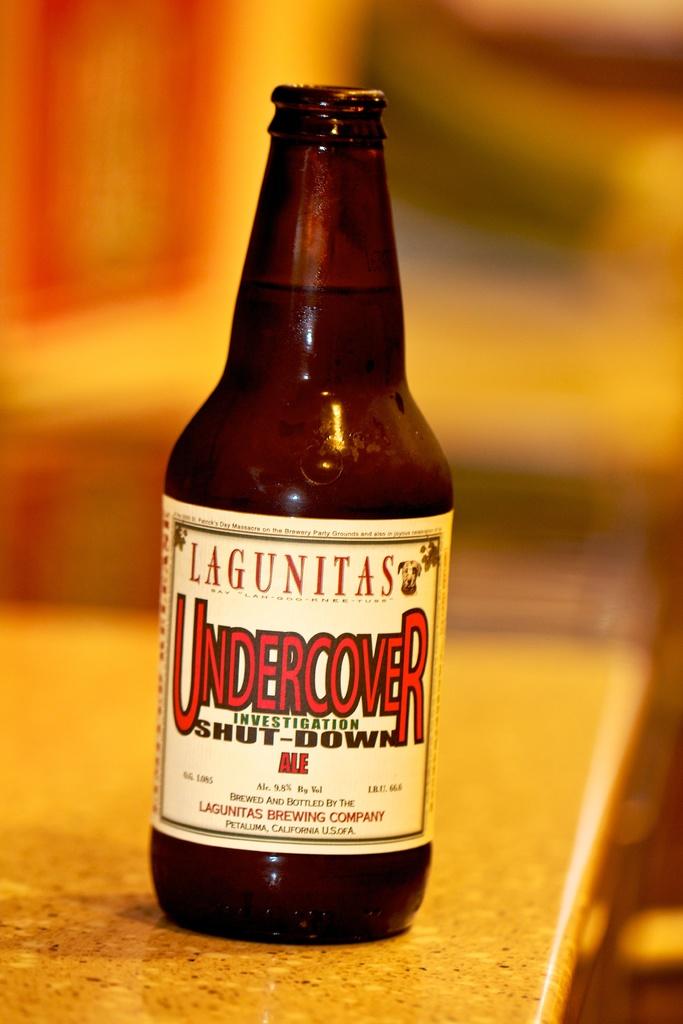Is this a bottle of undercover?
Give a very brief answer. Yes. 